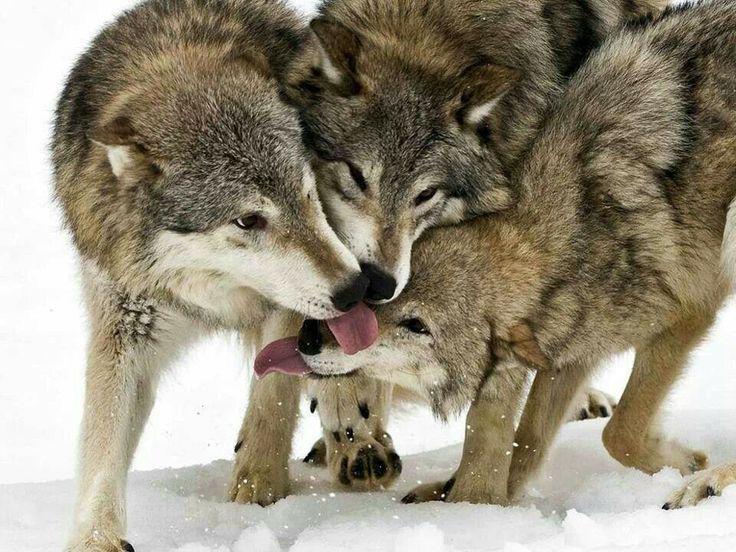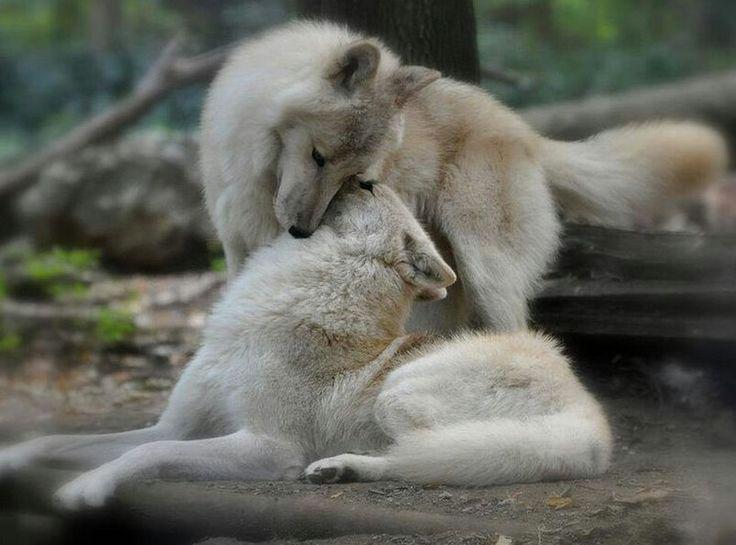The first image is the image on the left, the second image is the image on the right. Evaluate the accuracy of this statement regarding the images: "At least one wolf has its tongue visible in the left image.". Is it true? Answer yes or no. Yes. The first image is the image on the left, the second image is the image on the right. Evaluate the accuracy of this statement regarding the images: "All wolves are touching each other's faces in an affectionate way.". Is it true? Answer yes or no. Yes. 